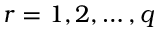<formula> <loc_0><loc_0><loc_500><loc_500>r = 1 , 2 , \hdots , q</formula> 